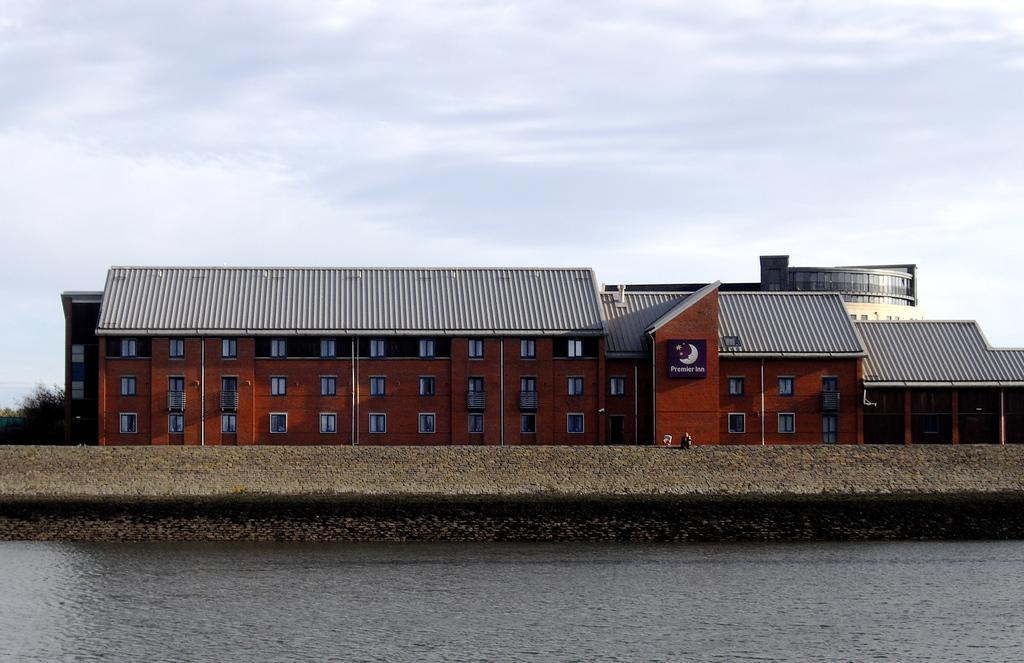What type of natural feature is present in the image? There is a river in the image. What is located behind the river? There is a building behind the river. How can the building be described? The building has many windows. What type of tax is being discussed in the image? There is no discussion of tax in the image; it features a river and a building with many windows. 